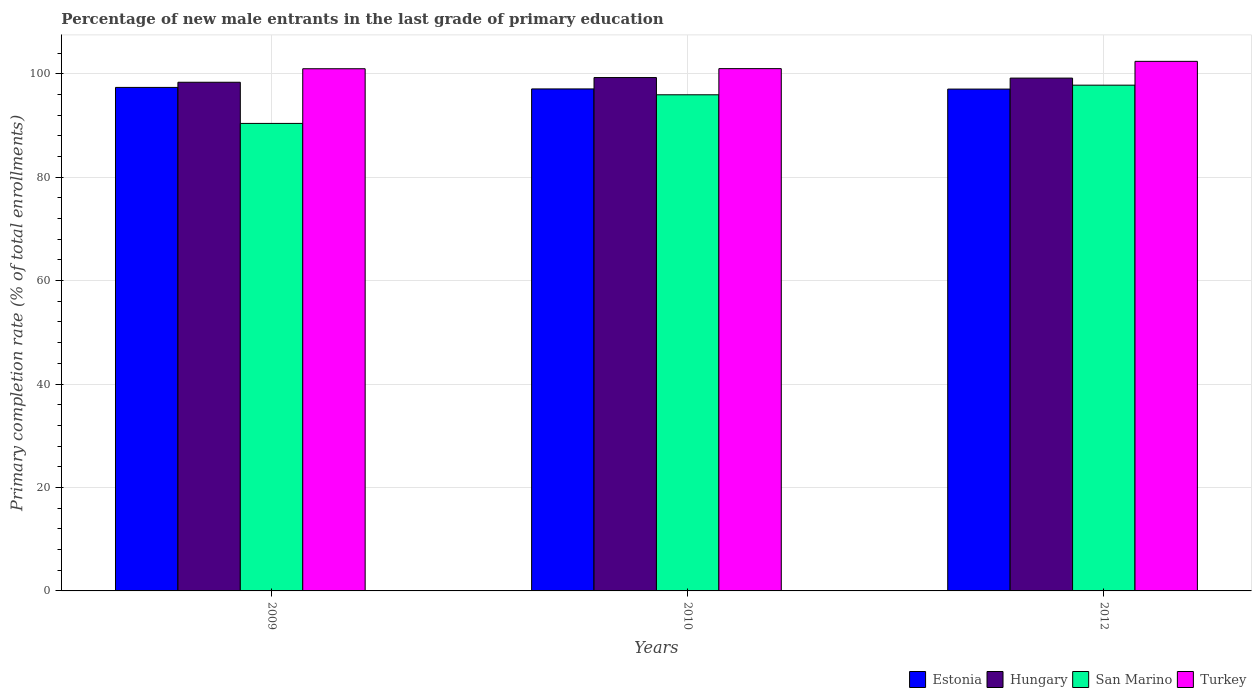How many different coloured bars are there?
Keep it short and to the point. 4. Are the number of bars per tick equal to the number of legend labels?
Offer a terse response. Yes. Are the number of bars on each tick of the X-axis equal?
Offer a terse response. Yes. How many bars are there on the 2nd tick from the left?
Offer a very short reply. 4. How many bars are there on the 2nd tick from the right?
Offer a very short reply. 4. What is the percentage of new male entrants in Turkey in 2010?
Ensure brevity in your answer.  100.99. Across all years, what is the maximum percentage of new male entrants in San Marino?
Give a very brief answer. 97.79. Across all years, what is the minimum percentage of new male entrants in Hungary?
Your answer should be compact. 98.35. In which year was the percentage of new male entrants in Turkey maximum?
Provide a succinct answer. 2012. In which year was the percentage of new male entrants in San Marino minimum?
Give a very brief answer. 2009. What is the total percentage of new male entrants in Turkey in the graph?
Your response must be concise. 304.35. What is the difference between the percentage of new male entrants in Turkey in 2009 and that in 2010?
Provide a short and direct response. -0.02. What is the difference between the percentage of new male entrants in Turkey in 2009 and the percentage of new male entrants in Estonia in 2012?
Your answer should be very brief. 3.93. What is the average percentage of new male entrants in Hungary per year?
Offer a very short reply. 98.92. In the year 2010, what is the difference between the percentage of new male entrants in Turkey and percentage of new male entrants in San Marino?
Keep it short and to the point. 5.06. What is the ratio of the percentage of new male entrants in San Marino in 2009 to that in 2012?
Offer a terse response. 0.92. What is the difference between the highest and the second highest percentage of new male entrants in San Marino?
Provide a succinct answer. 1.86. What is the difference between the highest and the lowest percentage of new male entrants in San Marino?
Provide a succinct answer. 7.39. What does the 1st bar from the left in 2010 represents?
Provide a short and direct response. Estonia. What does the 3rd bar from the right in 2010 represents?
Make the answer very short. Hungary. How many bars are there?
Make the answer very short. 12. How many years are there in the graph?
Offer a terse response. 3. Does the graph contain any zero values?
Provide a succinct answer. No. Does the graph contain grids?
Your answer should be very brief. Yes. Where does the legend appear in the graph?
Keep it short and to the point. Bottom right. What is the title of the graph?
Keep it short and to the point. Percentage of new male entrants in the last grade of primary education. What is the label or title of the X-axis?
Make the answer very short. Years. What is the label or title of the Y-axis?
Give a very brief answer. Primary completion rate (% of total enrollments). What is the Primary completion rate (% of total enrollments) in Estonia in 2009?
Keep it short and to the point. 97.36. What is the Primary completion rate (% of total enrollments) of Hungary in 2009?
Your response must be concise. 98.35. What is the Primary completion rate (% of total enrollments) of San Marino in 2009?
Your answer should be very brief. 90.4. What is the Primary completion rate (% of total enrollments) in Turkey in 2009?
Give a very brief answer. 100.97. What is the Primary completion rate (% of total enrollments) of Estonia in 2010?
Provide a short and direct response. 97.06. What is the Primary completion rate (% of total enrollments) in Hungary in 2010?
Ensure brevity in your answer.  99.26. What is the Primary completion rate (% of total enrollments) in San Marino in 2010?
Offer a terse response. 95.93. What is the Primary completion rate (% of total enrollments) of Turkey in 2010?
Your answer should be very brief. 100.99. What is the Primary completion rate (% of total enrollments) of Estonia in 2012?
Offer a terse response. 97.03. What is the Primary completion rate (% of total enrollments) in Hungary in 2012?
Ensure brevity in your answer.  99.16. What is the Primary completion rate (% of total enrollments) of San Marino in 2012?
Your response must be concise. 97.79. What is the Primary completion rate (% of total enrollments) in Turkey in 2012?
Provide a succinct answer. 102.39. Across all years, what is the maximum Primary completion rate (% of total enrollments) of Estonia?
Ensure brevity in your answer.  97.36. Across all years, what is the maximum Primary completion rate (% of total enrollments) in Hungary?
Give a very brief answer. 99.26. Across all years, what is the maximum Primary completion rate (% of total enrollments) in San Marino?
Give a very brief answer. 97.79. Across all years, what is the maximum Primary completion rate (% of total enrollments) of Turkey?
Your response must be concise. 102.39. Across all years, what is the minimum Primary completion rate (% of total enrollments) of Estonia?
Keep it short and to the point. 97.03. Across all years, what is the minimum Primary completion rate (% of total enrollments) of Hungary?
Offer a very short reply. 98.35. Across all years, what is the minimum Primary completion rate (% of total enrollments) in San Marino?
Offer a terse response. 90.4. Across all years, what is the minimum Primary completion rate (% of total enrollments) in Turkey?
Your response must be concise. 100.97. What is the total Primary completion rate (% of total enrollments) in Estonia in the graph?
Keep it short and to the point. 291.45. What is the total Primary completion rate (% of total enrollments) in Hungary in the graph?
Ensure brevity in your answer.  296.77. What is the total Primary completion rate (% of total enrollments) in San Marino in the graph?
Your response must be concise. 284.12. What is the total Primary completion rate (% of total enrollments) of Turkey in the graph?
Offer a very short reply. 304.35. What is the difference between the Primary completion rate (% of total enrollments) of Estonia in 2009 and that in 2010?
Provide a succinct answer. 0.29. What is the difference between the Primary completion rate (% of total enrollments) in Hungary in 2009 and that in 2010?
Your response must be concise. -0.91. What is the difference between the Primary completion rate (% of total enrollments) of San Marino in 2009 and that in 2010?
Your answer should be compact. -5.53. What is the difference between the Primary completion rate (% of total enrollments) in Turkey in 2009 and that in 2010?
Make the answer very short. -0.02. What is the difference between the Primary completion rate (% of total enrollments) of Estonia in 2009 and that in 2012?
Make the answer very short. 0.32. What is the difference between the Primary completion rate (% of total enrollments) in Hungary in 2009 and that in 2012?
Provide a short and direct response. -0.8. What is the difference between the Primary completion rate (% of total enrollments) in San Marino in 2009 and that in 2012?
Offer a very short reply. -7.39. What is the difference between the Primary completion rate (% of total enrollments) in Turkey in 2009 and that in 2012?
Keep it short and to the point. -1.43. What is the difference between the Primary completion rate (% of total enrollments) of Estonia in 2010 and that in 2012?
Make the answer very short. 0.03. What is the difference between the Primary completion rate (% of total enrollments) in Hungary in 2010 and that in 2012?
Keep it short and to the point. 0.11. What is the difference between the Primary completion rate (% of total enrollments) of San Marino in 2010 and that in 2012?
Give a very brief answer. -1.86. What is the difference between the Primary completion rate (% of total enrollments) of Turkey in 2010 and that in 2012?
Offer a terse response. -1.41. What is the difference between the Primary completion rate (% of total enrollments) of Estonia in 2009 and the Primary completion rate (% of total enrollments) of Hungary in 2010?
Provide a short and direct response. -1.91. What is the difference between the Primary completion rate (% of total enrollments) in Estonia in 2009 and the Primary completion rate (% of total enrollments) in San Marino in 2010?
Your response must be concise. 1.43. What is the difference between the Primary completion rate (% of total enrollments) in Estonia in 2009 and the Primary completion rate (% of total enrollments) in Turkey in 2010?
Give a very brief answer. -3.63. What is the difference between the Primary completion rate (% of total enrollments) in Hungary in 2009 and the Primary completion rate (% of total enrollments) in San Marino in 2010?
Give a very brief answer. 2.42. What is the difference between the Primary completion rate (% of total enrollments) in Hungary in 2009 and the Primary completion rate (% of total enrollments) in Turkey in 2010?
Offer a terse response. -2.63. What is the difference between the Primary completion rate (% of total enrollments) in San Marino in 2009 and the Primary completion rate (% of total enrollments) in Turkey in 2010?
Your answer should be very brief. -10.59. What is the difference between the Primary completion rate (% of total enrollments) in Estonia in 2009 and the Primary completion rate (% of total enrollments) in Hungary in 2012?
Make the answer very short. -1.8. What is the difference between the Primary completion rate (% of total enrollments) of Estonia in 2009 and the Primary completion rate (% of total enrollments) of San Marino in 2012?
Your response must be concise. -0.43. What is the difference between the Primary completion rate (% of total enrollments) in Estonia in 2009 and the Primary completion rate (% of total enrollments) in Turkey in 2012?
Your answer should be compact. -5.04. What is the difference between the Primary completion rate (% of total enrollments) in Hungary in 2009 and the Primary completion rate (% of total enrollments) in San Marino in 2012?
Your answer should be compact. 0.56. What is the difference between the Primary completion rate (% of total enrollments) in Hungary in 2009 and the Primary completion rate (% of total enrollments) in Turkey in 2012?
Provide a short and direct response. -4.04. What is the difference between the Primary completion rate (% of total enrollments) in San Marino in 2009 and the Primary completion rate (% of total enrollments) in Turkey in 2012?
Make the answer very short. -12. What is the difference between the Primary completion rate (% of total enrollments) in Estonia in 2010 and the Primary completion rate (% of total enrollments) in Hungary in 2012?
Keep it short and to the point. -2.09. What is the difference between the Primary completion rate (% of total enrollments) of Estonia in 2010 and the Primary completion rate (% of total enrollments) of San Marino in 2012?
Make the answer very short. -0.73. What is the difference between the Primary completion rate (% of total enrollments) in Estonia in 2010 and the Primary completion rate (% of total enrollments) in Turkey in 2012?
Keep it short and to the point. -5.33. What is the difference between the Primary completion rate (% of total enrollments) in Hungary in 2010 and the Primary completion rate (% of total enrollments) in San Marino in 2012?
Ensure brevity in your answer.  1.47. What is the difference between the Primary completion rate (% of total enrollments) of Hungary in 2010 and the Primary completion rate (% of total enrollments) of Turkey in 2012?
Offer a terse response. -3.13. What is the difference between the Primary completion rate (% of total enrollments) of San Marino in 2010 and the Primary completion rate (% of total enrollments) of Turkey in 2012?
Ensure brevity in your answer.  -6.46. What is the average Primary completion rate (% of total enrollments) of Estonia per year?
Ensure brevity in your answer.  97.15. What is the average Primary completion rate (% of total enrollments) of Hungary per year?
Your answer should be compact. 98.92. What is the average Primary completion rate (% of total enrollments) of San Marino per year?
Your response must be concise. 94.71. What is the average Primary completion rate (% of total enrollments) of Turkey per year?
Give a very brief answer. 101.45. In the year 2009, what is the difference between the Primary completion rate (% of total enrollments) of Estonia and Primary completion rate (% of total enrollments) of Hungary?
Your answer should be very brief. -1. In the year 2009, what is the difference between the Primary completion rate (% of total enrollments) of Estonia and Primary completion rate (% of total enrollments) of San Marino?
Make the answer very short. 6.96. In the year 2009, what is the difference between the Primary completion rate (% of total enrollments) in Estonia and Primary completion rate (% of total enrollments) in Turkey?
Make the answer very short. -3.61. In the year 2009, what is the difference between the Primary completion rate (% of total enrollments) of Hungary and Primary completion rate (% of total enrollments) of San Marino?
Provide a short and direct response. 7.96. In the year 2009, what is the difference between the Primary completion rate (% of total enrollments) of Hungary and Primary completion rate (% of total enrollments) of Turkey?
Your response must be concise. -2.61. In the year 2009, what is the difference between the Primary completion rate (% of total enrollments) of San Marino and Primary completion rate (% of total enrollments) of Turkey?
Give a very brief answer. -10.57. In the year 2010, what is the difference between the Primary completion rate (% of total enrollments) in Estonia and Primary completion rate (% of total enrollments) in Hungary?
Your answer should be very brief. -2.2. In the year 2010, what is the difference between the Primary completion rate (% of total enrollments) in Estonia and Primary completion rate (% of total enrollments) in San Marino?
Provide a succinct answer. 1.13. In the year 2010, what is the difference between the Primary completion rate (% of total enrollments) in Estonia and Primary completion rate (% of total enrollments) in Turkey?
Provide a short and direct response. -3.92. In the year 2010, what is the difference between the Primary completion rate (% of total enrollments) of Hungary and Primary completion rate (% of total enrollments) of San Marino?
Provide a short and direct response. 3.33. In the year 2010, what is the difference between the Primary completion rate (% of total enrollments) in Hungary and Primary completion rate (% of total enrollments) in Turkey?
Ensure brevity in your answer.  -1.73. In the year 2010, what is the difference between the Primary completion rate (% of total enrollments) in San Marino and Primary completion rate (% of total enrollments) in Turkey?
Provide a short and direct response. -5.06. In the year 2012, what is the difference between the Primary completion rate (% of total enrollments) in Estonia and Primary completion rate (% of total enrollments) in Hungary?
Provide a short and direct response. -2.12. In the year 2012, what is the difference between the Primary completion rate (% of total enrollments) in Estonia and Primary completion rate (% of total enrollments) in San Marino?
Your answer should be compact. -0.76. In the year 2012, what is the difference between the Primary completion rate (% of total enrollments) in Estonia and Primary completion rate (% of total enrollments) in Turkey?
Your answer should be compact. -5.36. In the year 2012, what is the difference between the Primary completion rate (% of total enrollments) in Hungary and Primary completion rate (% of total enrollments) in San Marino?
Ensure brevity in your answer.  1.37. In the year 2012, what is the difference between the Primary completion rate (% of total enrollments) of Hungary and Primary completion rate (% of total enrollments) of Turkey?
Keep it short and to the point. -3.24. In the year 2012, what is the difference between the Primary completion rate (% of total enrollments) of San Marino and Primary completion rate (% of total enrollments) of Turkey?
Offer a terse response. -4.6. What is the ratio of the Primary completion rate (% of total enrollments) of Hungary in 2009 to that in 2010?
Ensure brevity in your answer.  0.99. What is the ratio of the Primary completion rate (% of total enrollments) in San Marino in 2009 to that in 2010?
Give a very brief answer. 0.94. What is the ratio of the Primary completion rate (% of total enrollments) in Turkey in 2009 to that in 2010?
Offer a terse response. 1. What is the ratio of the Primary completion rate (% of total enrollments) of San Marino in 2009 to that in 2012?
Ensure brevity in your answer.  0.92. What is the ratio of the Primary completion rate (% of total enrollments) in Turkey in 2009 to that in 2012?
Offer a very short reply. 0.99. What is the ratio of the Primary completion rate (% of total enrollments) in Hungary in 2010 to that in 2012?
Make the answer very short. 1. What is the ratio of the Primary completion rate (% of total enrollments) in San Marino in 2010 to that in 2012?
Your response must be concise. 0.98. What is the ratio of the Primary completion rate (% of total enrollments) of Turkey in 2010 to that in 2012?
Give a very brief answer. 0.99. What is the difference between the highest and the second highest Primary completion rate (% of total enrollments) of Estonia?
Provide a succinct answer. 0.29. What is the difference between the highest and the second highest Primary completion rate (% of total enrollments) in Hungary?
Ensure brevity in your answer.  0.11. What is the difference between the highest and the second highest Primary completion rate (% of total enrollments) in San Marino?
Provide a succinct answer. 1.86. What is the difference between the highest and the second highest Primary completion rate (% of total enrollments) of Turkey?
Offer a terse response. 1.41. What is the difference between the highest and the lowest Primary completion rate (% of total enrollments) in Estonia?
Keep it short and to the point. 0.32. What is the difference between the highest and the lowest Primary completion rate (% of total enrollments) of Hungary?
Make the answer very short. 0.91. What is the difference between the highest and the lowest Primary completion rate (% of total enrollments) of San Marino?
Provide a succinct answer. 7.39. What is the difference between the highest and the lowest Primary completion rate (% of total enrollments) in Turkey?
Offer a terse response. 1.43. 